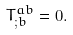Convert formula to latex. <formula><loc_0><loc_0><loc_500><loc_500>T ^ { a b } _ { ; b } = 0 .</formula> 